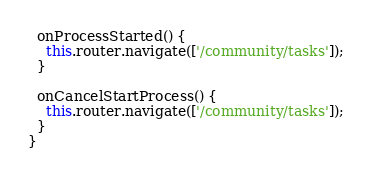Convert code to text. <code><loc_0><loc_0><loc_500><loc_500><_TypeScript_>
  onProcessStarted() {
    this.router.navigate(['/community/tasks']);
  }

  onCancelStartProcess() {
    this.router.navigate(['/community/tasks']);
  }
}
</code> 